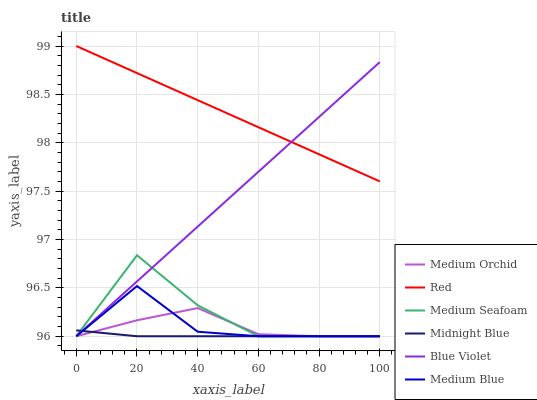Does Midnight Blue have the minimum area under the curve?
Answer yes or no. Yes. Does Red have the maximum area under the curve?
Answer yes or no. Yes. Does Medium Orchid have the minimum area under the curve?
Answer yes or no. No. Does Medium Orchid have the maximum area under the curve?
Answer yes or no. No. Is Blue Violet the smoothest?
Answer yes or no. Yes. Is Medium Seafoam the roughest?
Answer yes or no. Yes. Is Medium Orchid the smoothest?
Answer yes or no. No. Is Medium Orchid the roughest?
Answer yes or no. No. Does Midnight Blue have the lowest value?
Answer yes or no. Yes. Does Red have the lowest value?
Answer yes or no. No. Does Red have the highest value?
Answer yes or no. Yes. Does Medium Orchid have the highest value?
Answer yes or no. No. Is Midnight Blue less than Red?
Answer yes or no. Yes. Is Red greater than Midnight Blue?
Answer yes or no. Yes. Does Blue Violet intersect Midnight Blue?
Answer yes or no. Yes. Is Blue Violet less than Midnight Blue?
Answer yes or no. No. Is Blue Violet greater than Midnight Blue?
Answer yes or no. No. Does Midnight Blue intersect Red?
Answer yes or no. No. 